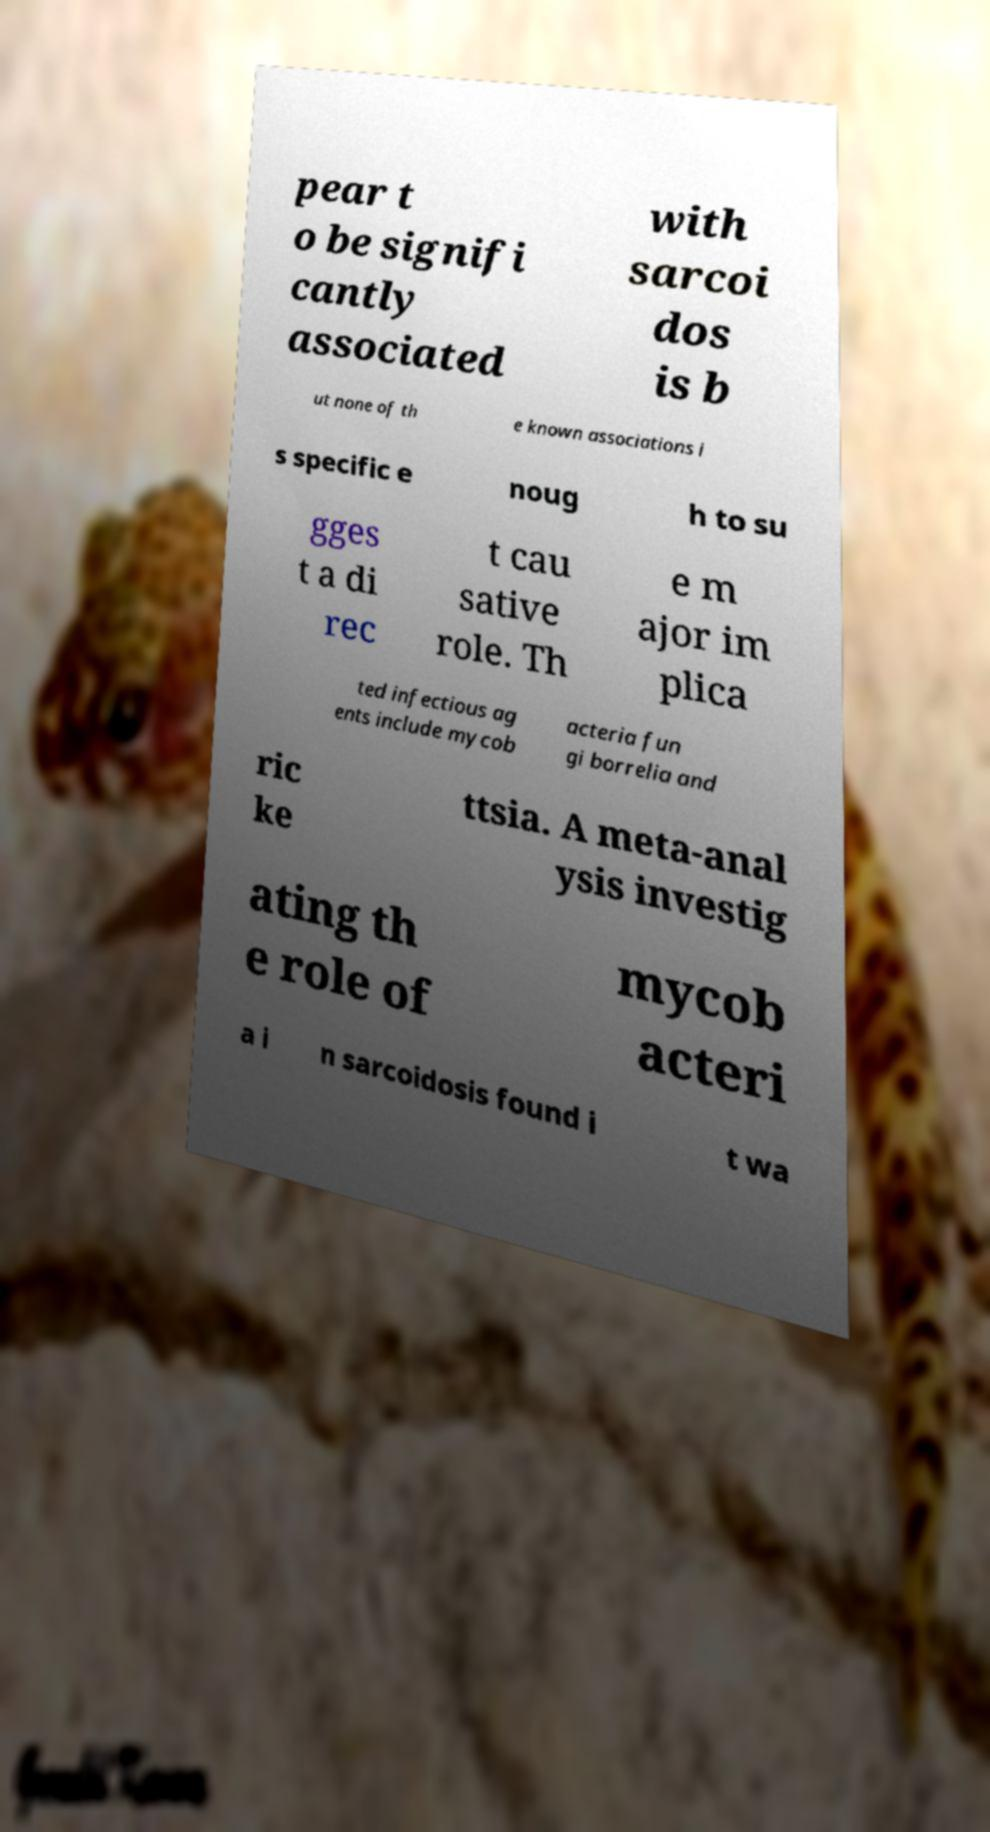There's text embedded in this image that I need extracted. Can you transcribe it verbatim? pear t o be signifi cantly associated with sarcoi dos is b ut none of th e known associations i s specific e noug h to su gges t a di rec t cau sative role. Th e m ajor im plica ted infectious ag ents include mycob acteria fun gi borrelia and ric ke ttsia. A meta-anal ysis investig ating th e role of mycob acteri a i n sarcoidosis found i t wa 